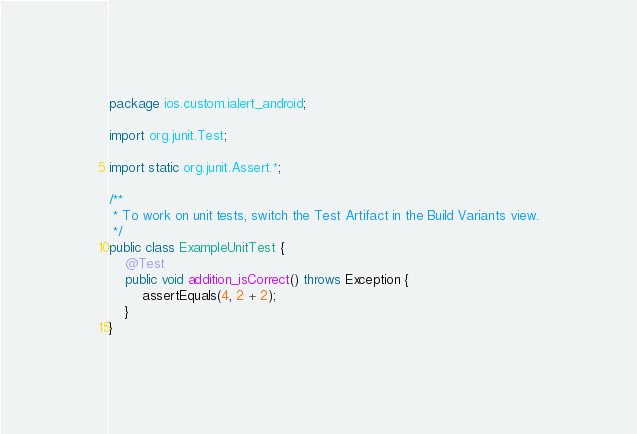Convert code to text. <code><loc_0><loc_0><loc_500><loc_500><_Java_>package ios.custom.ialert_android;

import org.junit.Test;

import static org.junit.Assert.*;

/**
 * To work on unit tests, switch the Test Artifact in the Build Variants view.
 */
public class ExampleUnitTest {
    @Test
    public void addition_isCorrect() throws Exception {
        assertEquals(4, 2 + 2);
    }
}</code> 